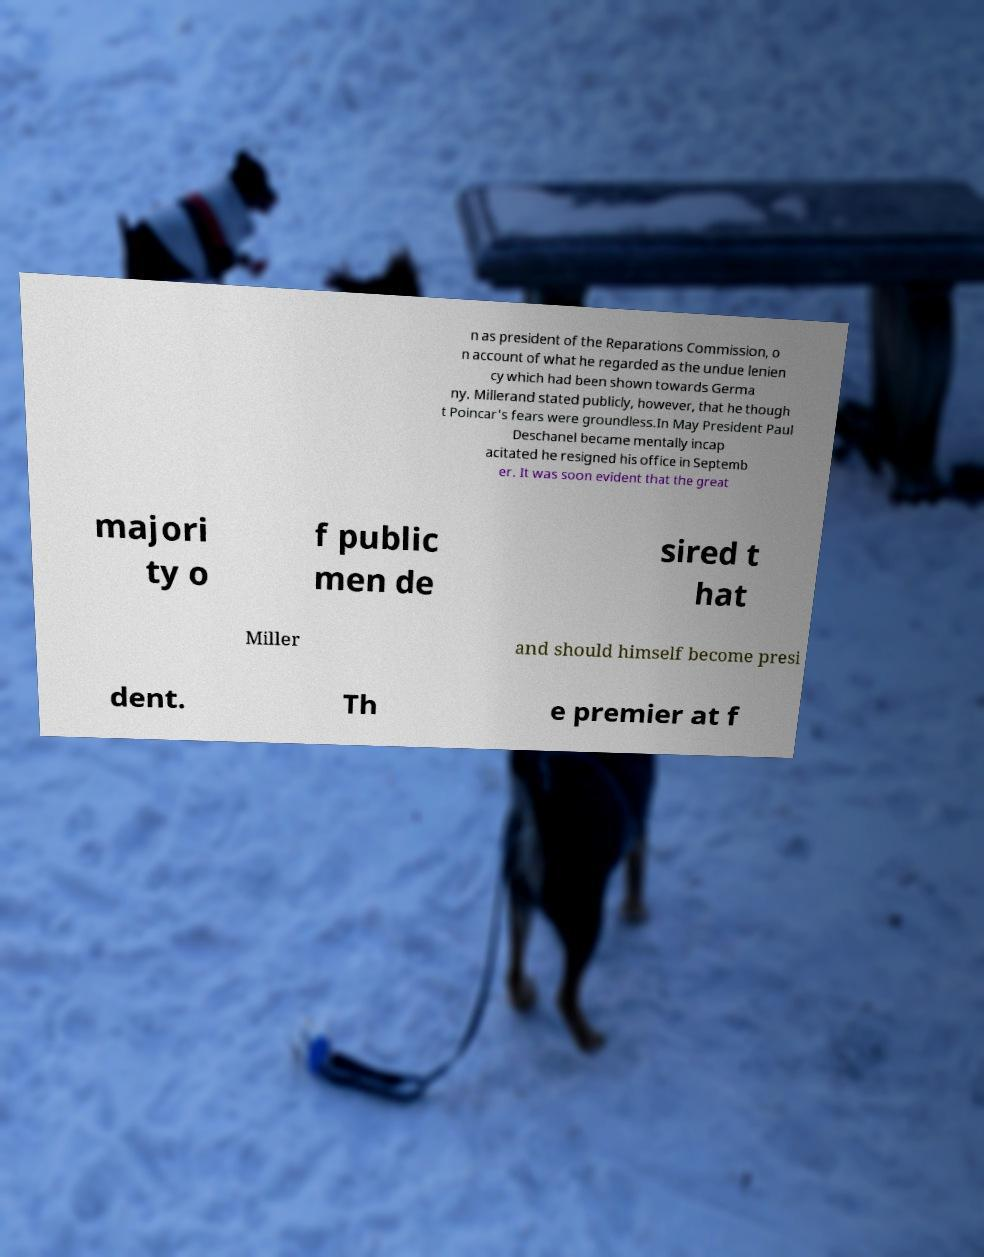What messages or text are displayed in this image? I need them in a readable, typed format. n as president of the Reparations Commission, o n account of what he regarded as the undue lenien cy which had been shown towards Germa ny. Millerand stated publicly, however, that he though t Poincar's fears were groundless.In May President Paul Deschanel became mentally incap acitated he resigned his office in Septemb er. It was soon evident that the great majori ty o f public men de sired t hat Miller and should himself become presi dent. Th e premier at f 